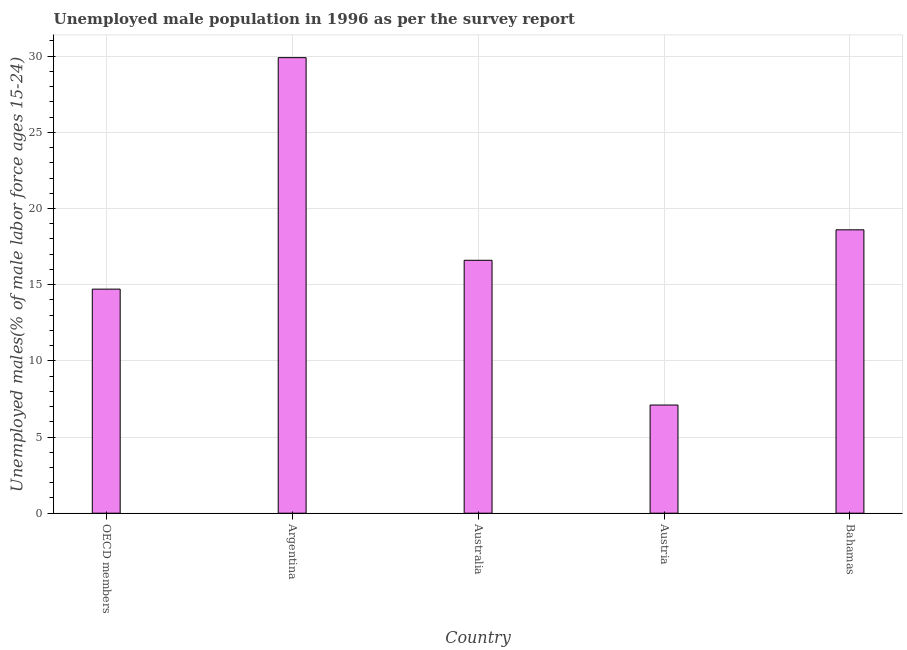Does the graph contain any zero values?
Make the answer very short. No. Does the graph contain grids?
Ensure brevity in your answer.  Yes. What is the title of the graph?
Provide a succinct answer. Unemployed male population in 1996 as per the survey report. What is the label or title of the Y-axis?
Offer a terse response. Unemployed males(% of male labor force ages 15-24). What is the unemployed male youth in Argentina?
Provide a succinct answer. 29.9. Across all countries, what is the maximum unemployed male youth?
Provide a short and direct response. 29.9. Across all countries, what is the minimum unemployed male youth?
Make the answer very short. 7.1. In which country was the unemployed male youth maximum?
Keep it short and to the point. Argentina. What is the sum of the unemployed male youth?
Keep it short and to the point. 86.91. What is the difference between the unemployed male youth in Bahamas and OECD members?
Your answer should be very brief. 3.89. What is the average unemployed male youth per country?
Provide a short and direct response. 17.38. What is the median unemployed male youth?
Keep it short and to the point. 16.6. What is the ratio of the unemployed male youth in Australia to that in Bahamas?
Provide a succinct answer. 0.89. Is the difference between the unemployed male youth in Australia and Austria greater than the difference between any two countries?
Give a very brief answer. No. What is the difference between the highest and the lowest unemployed male youth?
Your answer should be compact. 22.8. How many bars are there?
Your response must be concise. 5. Are all the bars in the graph horizontal?
Your answer should be compact. No. What is the difference between two consecutive major ticks on the Y-axis?
Give a very brief answer. 5. Are the values on the major ticks of Y-axis written in scientific E-notation?
Your answer should be compact. No. What is the Unemployed males(% of male labor force ages 15-24) in OECD members?
Keep it short and to the point. 14.71. What is the Unemployed males(% of male labor force ages 15-24) of Argentina?
Offer a very short reply. 29.9. What is the Unemployed males(% of male labor force ages 15-24) of Australia?
Your answer should be compact. 16.6. What is the Unemployed males(% of male labor force ages 15-24) in Austria?
Provide a short and direct response. 7.1. What is the Unemployed males(% of male labor force ages 15-24) of Bahamas?
Offer a terse response. 18.6. What is the difference between the Unemployed males(% of male labor force ages 15-24) in OECD members and Argentina?
Give a very brief answer. -15.19. What is the difference between the Unemployed males(% of male labor force ages 15-24) in OECD members and Australia?
Offer a terse response. -1.89. What is the difference between the Unemployed males(% of male labor force ages 15-24) in OECD members and Austria?
Provide a short and direct response. 7.61. What is the difference between the Unemployed males(% of male labor force ages 15-24) in OECD members and Bahamas?
Ensure brevity in your answer.  -3.89. What is the difference between the Unemployed males(% of male labor force ages 15-24) in Argentina and Austria?
Your answer should be compact. 22.8. What is the ratio of the Unemployed males(% of male labor force ages 15-24) in OECD members to that in Argentina?
Provide a succinct answer. 0.49. What is the ratio of the Unemployed males(% of male labor force ages 15-24) in OECD members to that in Australia?
Give a very brief answer. 0.89. What is the ratio of the Unemployed males(% of male labor force ages 15-24) in OECD members to that in Austria?
Your answer should be compact. 2.07. What is the ratio of the Unemployed males(% of male labor force ages 15-24) in OECD members to that in Bahamas?
Give a very brief answer. 0.79. What is the ratio of the Unemployed males(% of male labor force ages 15-24) in Argentina to that in Australia?
Your answer should be very brief. 1.8. What is the ratio of the Unemployed males(% of male labor force ages 15-24) in Argentina to that in Austria?
Give a very brief answer. 4.21. What is the ratio of the Unemployed males(% of male labor force ages 15-24) in Argentina to that in Bahamas?
Your response must be concise. 1.61. What is the ratio of the Unemployed males(% of male labor force ages 15-24) in Australia to that in Austria?
Make the answer very short. 2.34. What is the ratio of the Unemployed males(% of male labor force ages 15-24) in Australia to that in Bahamas?
Give a very brief answer. 0.89. What is the ratio of the Unemployed males(% of male labor force ages 15-24) in Austria to that in Bahamas?
Make the answer very short. 0.38. 